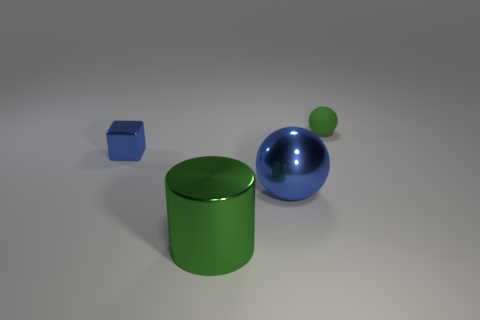Add 4 metal spheres. How many objects exist? 8 Subtract all cubes. How many objects are left? 3 Subtract all large cyan metallic cubes. Subtract all cylinders. How many objects are left? 3 Add 3 green metal objects. How many green metal objects are left? 4 Add 4 large blue metal objects. How many large blue metal objects exist? 5 Subtract 1 blue balls. How many objects are left? 3 